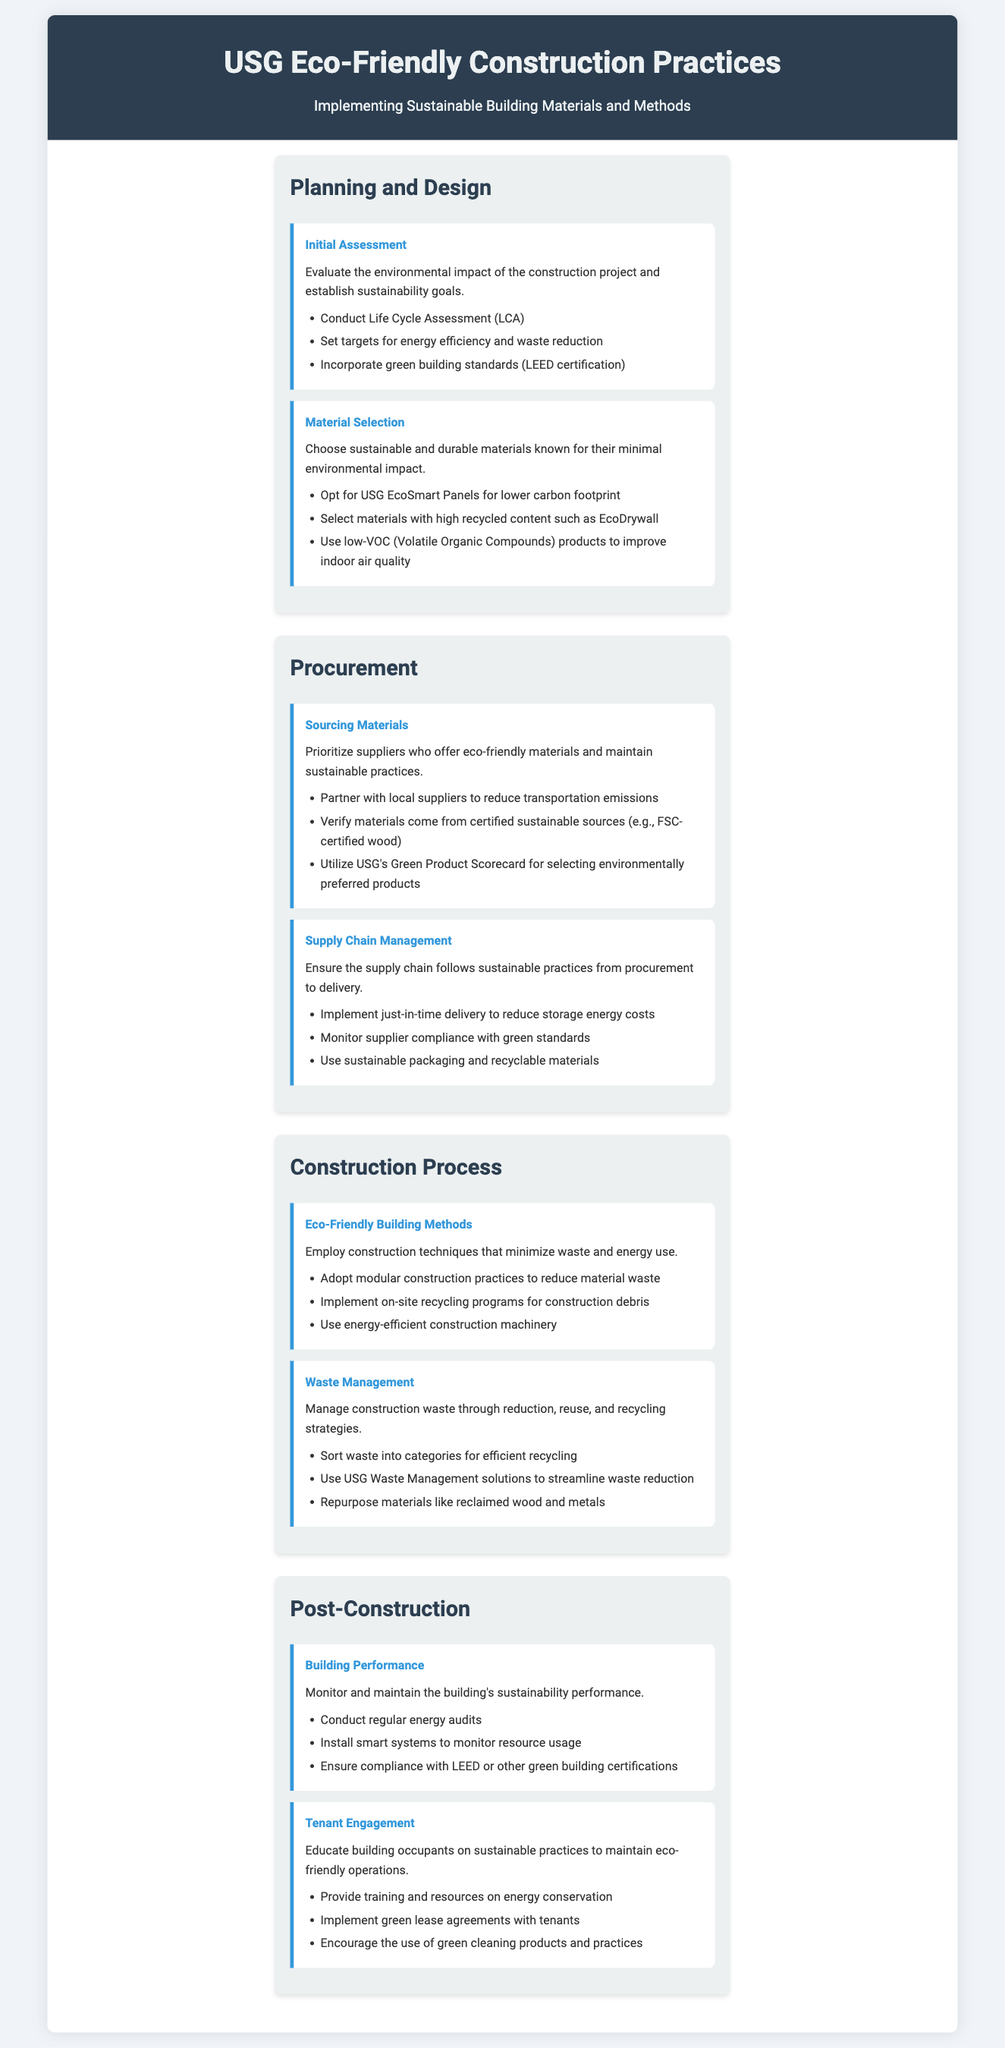what is the first step in the Planning and Design phase? The first step listed is to evaluate the environmental impact of the construction project and establish sustainability goals.
Answer: Initial Assessment what standard should be incorporated in Material Selection? The document specifies incorporating green building standards intended to ensure sustainable practices.
Answer: LEED certification what is prioritized in the Sourcing Materials step? The Sourcing Materials step emphasizes the importance of choosing suppliers who offer eco-friendly materials.
Answer: eco-friendly materials how many sections are there in the document? The document outlines various aspects of the process in four main sections.
Answer: Four what technique can reduce material waste in the Construction Process? The document suggests adopting modular construction practices as a means to minimize material waste during the building process.
Answer: modular construction which USG product is mentioned for lower carbon footprint? The document specifically mentions a type of building panel that is designed to have a reduced impact on the environment.
Answer: USG EcoSmart Panels what is the aim of conducting energy audits in the Post-Construction phase? The regular audits are meant to monitor the building's sustainability performance after construction is complete.
Answer: building performance how can tenant engagement contribute to sustainability? Educating building occupants on sustainable practices can help achieve continued eco-friendly operations within the building.
Answer: sustainable practices what is a recommended practice for waste management during construction? The document advises sorting construction waste into categories for efficient recycling as a standard operational procedure.
Answer: sort waste which system is suggested for monitoring resource usage? The document recommends installing advanced systems to track and improve the efficiency of resource usage in the building.
Answer: smart systems 